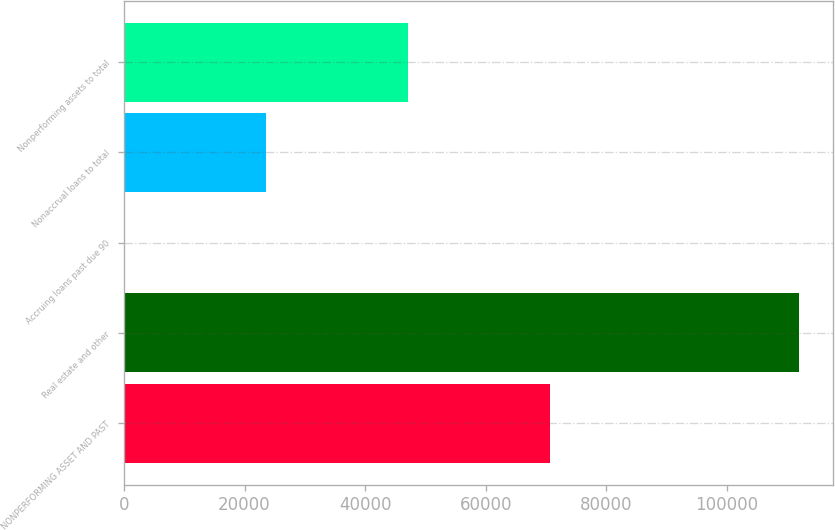Convert chart. <chart><loc_0><loc_0><loc_500><loc_500><bar_chart><fcel>NONPERFORMING ASSET AND PAST<fcel>Real estate and other<fcel>Accruing loans past due 90<fcel>Nonaccrual loans to total<fcel>Nonperforming assets to total<nl><fcel>70646.9<fcel>111910<fcel>0.28<fcel>23549.2<fcel>47098<nl></chart> 